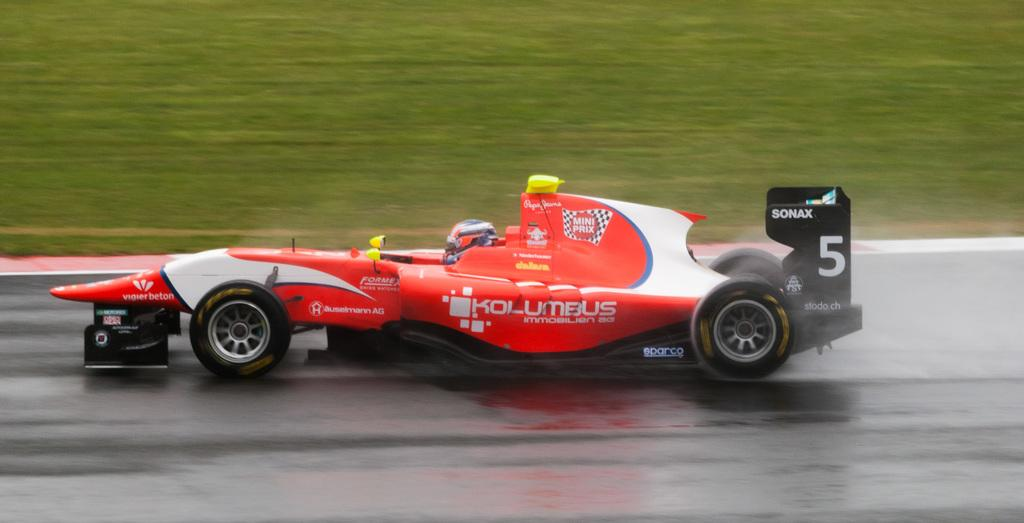What is the main subject of the image? The main subject of the image is a racing car. Where is the racing car located in the image? The racing car is standing on the road in the image. Who is inside the racing car? There is a person sitting in the racing car. What protective gear is the person wearing? The person is wearing a helmet. What can be seen in the background of the image? The background of the image shows a ground covered with grass. What type of pollution can be seen coming from the racing car in the image? There is no visible pollution coming from the racing car in the image. Can you tell me where the office is located in the image? There is no office present in the image; it features a racing car on the road with a person wearing a helmet. 